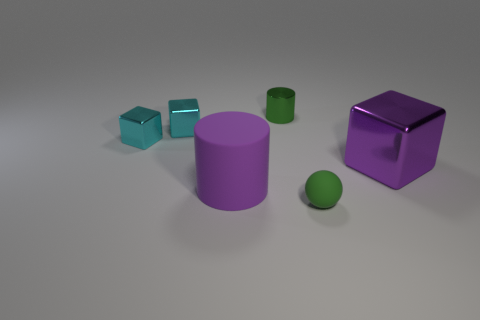Do the big object that is on the right side of the green rubber ball and the purple thing that is on the left side of the sphere have the same material? no 